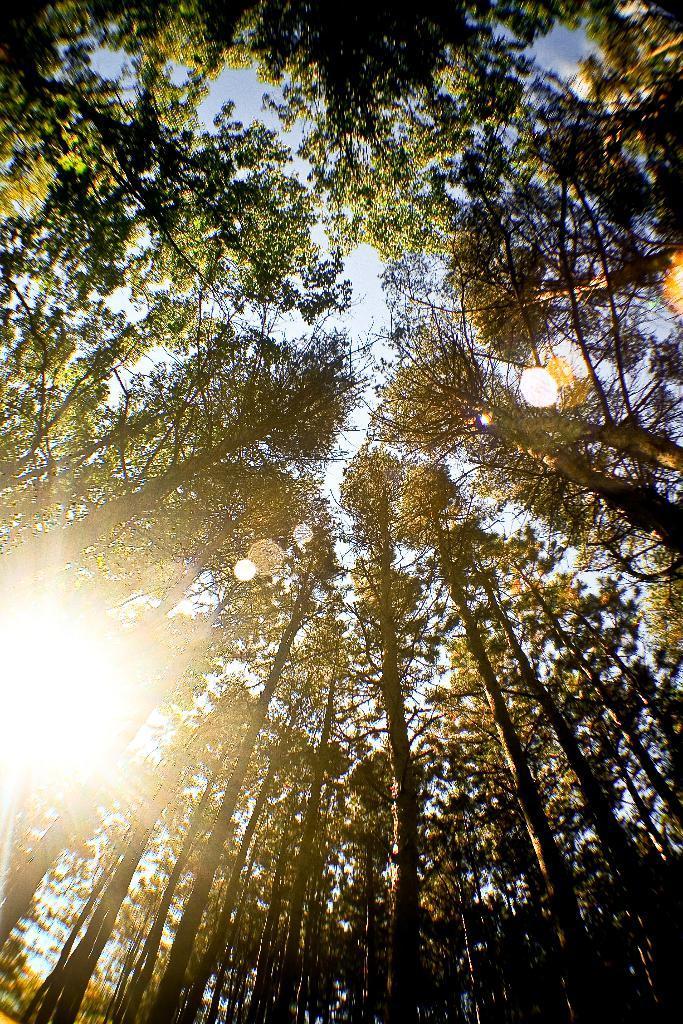In one or two sentences, can you explain what this image depicts? In this image we can see the trees and in the background, we can see the sky and also the sunlight. 